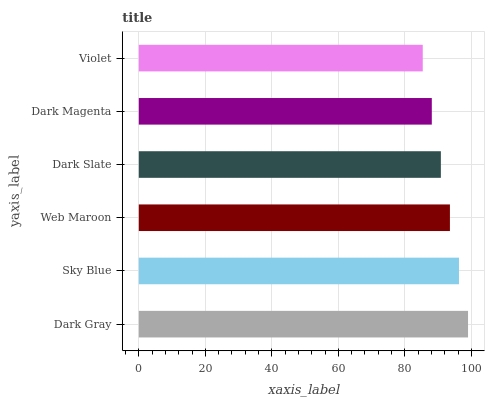Is Violet the minimum?
Answer yes or no. Yes. Is Dark Gray the maximum?
Answer yes or no. Yes. Is Sky Blue the minimum?
Answer yes or no. No. Is Sky Blue the maximum?
Answer yes or no. No. Is Dark Gray greater than Sky Blue?
Answer yes or no. Yes. Is Sky Blue less than Dark Gray?
Answer yes or no. Yes. Is Sky Blue greater than Dark Gray?
Answer yes or no. No. Is Dark Gray less than Sky Blue?
Answer yes or no. No. Is Web Maroon the high median?
Answer yes or no. Yes. Is Dark Slate the low median?
Answer yes or no. Yes. Is Dark Gray the high median?
Answer yes or no. No. Is Web Maroon the low median?
Answer yes or no. No. 